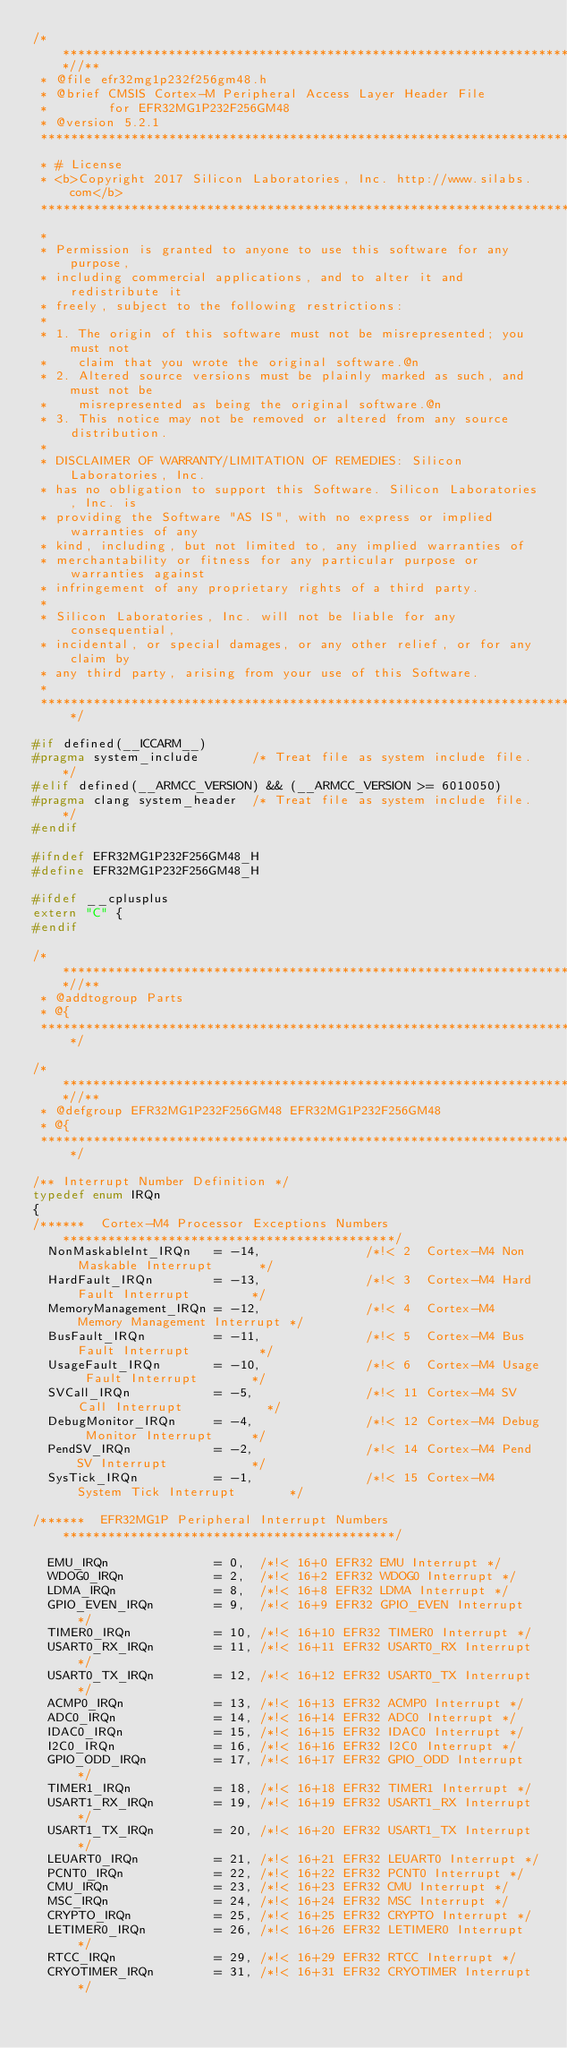<code> <loc_0><loc_0><loc_500><loc_500><_C_>/**************************************************************************//**
 * @file efr32mg1p232f256gm48.h
 * @brief CMSIS Cortex-M Peripheral Access Layer Header File
 *        for EFR32MG1P232F256GM48
 * @version 5.2.1
 ******************************************************************************
 * # License
 * <b>Copyright 2017 Silicon Laboratories, Inc. http://www.silabs.com</b>
 ******************************************************************************
 *
 * Permission is granted to anyone to use this software for any purpose,
 * including commercial applications, and to alter it and redistribute it
 * freely, subject to the following restrictions:
 *
 * 1. The origin of this software must not be misrepresented; you must not
 *    claim that you wrote the original software.@n
 * 2. Altered source versions must be plainly marked as such, and must not be
 *    misrepresented as being the original software.@n
 * 3. This notice may not be removed or altered from any source distribution.
 *
 * DISCLAIMER OF WARRANTY/LIMITATION OF REMEDIES: Silicon Laboratories, Inc.
 * has no obligation to support this Software. Silicon Laboratories, Inc. is
 * providing the Software "AS IS", with no express or implied warranties of any
 * kind, including, but not limited to, any implied warranties of
 * merchantability or fitness for any particular purpose or warranties against
 * infringement of any proprietary rights of a third party.
 *
 * Silicon Laboratories, Inc. will not be liable for any consequential,
 * incidental, or special damages, or any other relief, or for any claim by
 * any third party, arising from your use of this Software.
 *
 *****************************************************************************/

#if defined(__ICCARM__)
#pragma system_include       /* Treat file as system include file. */
#elif defined(__ARMCC_VERSION) && (__ARMCC_VERSION >= 6010050)
#pragma clang system_header  /* Treat file as system include file. */
#endif

#ifndef EFR32MG1P232F256GM48_H
#define EFR32MG1P232F256GM48_H

#ifdef __cplusplus
extern "C" {
#endif

/**************************************************************************//**
 * @addtogroup Parts
 * @{
 *****************************************************************************/

/**************************************************************************//**
 * @defgroup EFR32MG1P232F256GM48 EFR32MG1P232F256GM48
 * @{
 *****************************************************************************/

/** Interrupt Number Definition */
typedef enum IRQn
{
/******  Cortex-M4 Processor Exceptions Numbers ********************************************/
  NonMaskableInt_IRQn   = -14,              /*!< 2  Cortex-M4 Non Maskable Interrupt      */
  HardFault_IRQn        = -13,              /*!< 3  Cortex-M4 Hard Fault Interrupt        */
  MemoryManagement_IRQn = -12,              /*!< 4  Cortex-M4 Memory Management Interrupt */
  BusFault_IRQn         = -11,              /*!< 5  Cortex-M4 Bus Fault Interrupt         */
  UsageFault_IRQn       = -10,              /*!< 6  Cortex-M4 Usage Fault Interrupt       */
  SVCall_IRQn           = -5,               /*!< 11 Cortex-M4 SV Call Interrupt           */
  DebugMonitor_IRQn     = -4,               /*!< 12 Cortex-M4 Debug Monitor Interrupt     */
  PendSV_IRQn           = -2,               /*!< 14 Cortex-M4 Pend SV Interrupt           */
  SysTick_IRQn          = -1,               /*!< 15 Cortex-M4 System Tick Interrupt       */

/******  EFR32MG1P Peripheral Interrupt Numbers ********************************************/

  EMU_IRQn              = 0,  /*!< 16+0 EFR32 EMU Interrupt */
  WDOG0_IRQn            = 2,  /*!< 16+2 EFR32 WDOG0 Interrupt */
  LDMA_IRQn             = 8,  /*!< 16+8 EFR32 LDMA Interrupt */
  GPIO_EVEN_IRQn        = 9,  /*!< 16+9 EFR32 GPIO_EVEN Interrupt */
  TIMER0_IRQn           = 10, /*!< 16+10 EFR32 TIMER0 Interrupt */
  USART0_RX_IRQn        = 11, /*!< 16+11 EFR32 USART0_RX Interrupt */
  USART0_TX_IRQn        = 12, /*!< 16+12 EFR32 USART0_TX Interrupt */
  ACMP0_IRQn            = 13, /*!< 16+13 EFR32 ACMP0 Interrupt */
  ADC0_IRQn             = 14, /*!< 16+14 EFR32 ADC0 Interrupt */
  IDAC0_IRQn            = 15, /*!< 16+15 EFR32 IDAC0 Interrupt */
  I2C0_IRQn             = 16, /*!< 16+16 EFR32 I2C0 Interrupt */
  GPIO_ODD_IRQn         = 17, /*!< 16+17 EFR32 GPIO_ODD Interrupt */
  TIMER1_IRQn           = 18, /*!< 16+18 EFR32 TIMER1 Interrupt */
  USART1_RX_IRQn        = 19, /*!< 16+19 EFR32 USART1_RX Interrupt */
  USART1_TX_IRQn        = 20, /*!< 16+20 EFR32 USART1_TX Interrupt */
  LEUART0_IRQn          = 21, /*!< 16+21 EFR32 LEUART0 Interrupt */
  PCNT0_IRQn            = 22, /*!< 16+22 EFR32 PCNT0 Interrupt */
  CMU_IRQn              = 23, /*!< 16+23 EFR32 CMU Interrupt */
  MSC_IRQn              = 24, /*!< 16+24 EFR32 MSC Interrupt */
  CRYPTO_IRQn           = 25, /*!< 16+25 EFR32 CRYPTO Interrupt */
  LETIMER0_IRQn         = 26, /*!< 16+26 EFR32 LETIMER0 Interrupt */
  RTCC_IRQn             = 29, /*!< 16+29 EFR32 RTCC Interrupt */
  CRYOTIMER_IRQn        = 31, /*!< 16+31 EFR32 CRYOTIMER Interrupt */</code> 